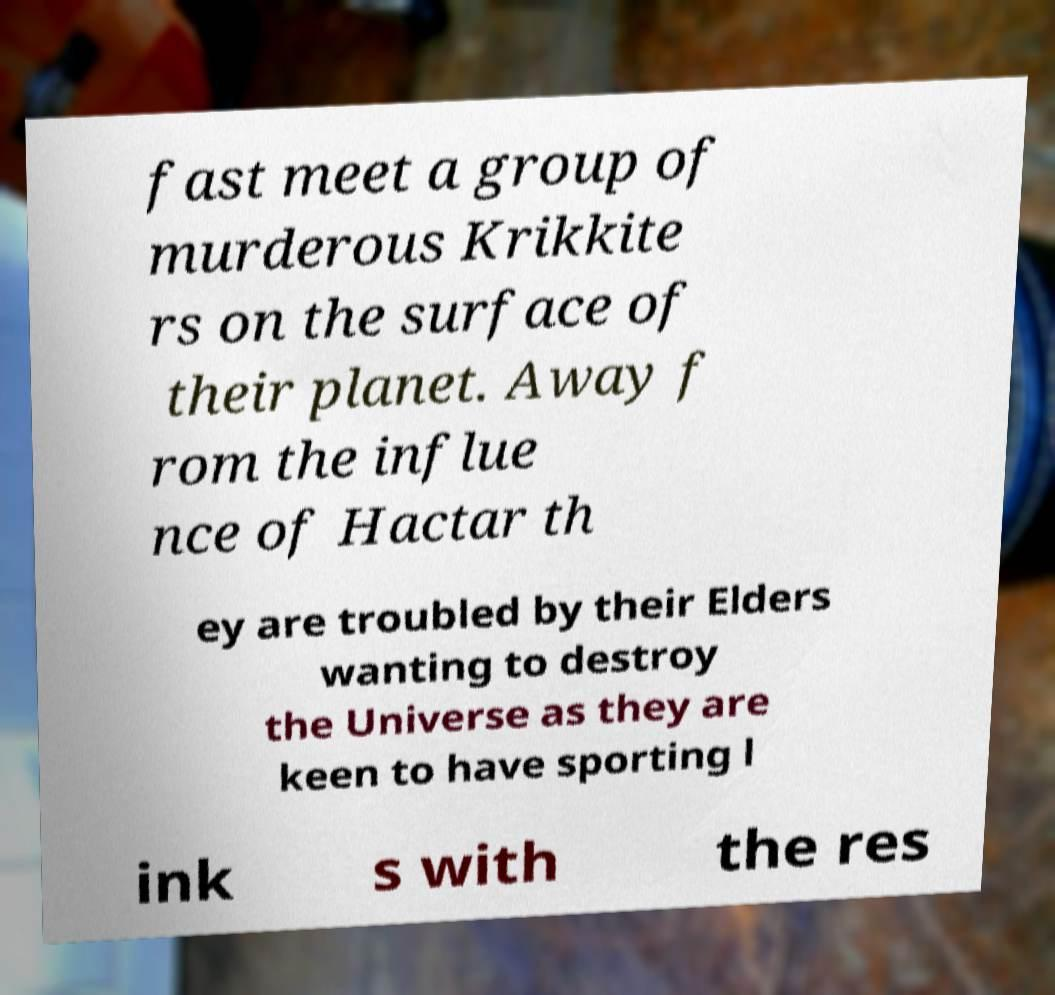Can you accurately transcribe the text from the provided image for me? fast meet a group of murderous Krikkite rs on the surface of their planet. Away f rom the influe nce of Hactar th ey are troubled by their Elders wanting to destroy the Universe as they are keen to have sporting l ink s with the res 